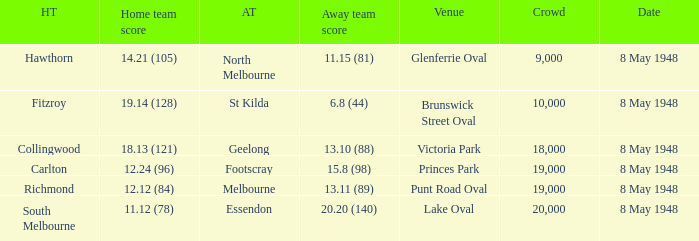How many spectators were at the game when the away team scored 15.8 (98)? 19000.0. 